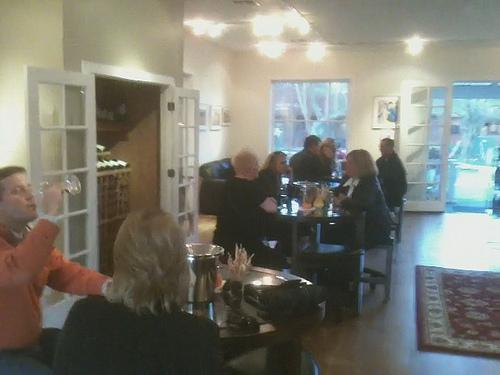Mention one prominent piece of furniture and its color in the image. A large red area rug is on the floor. Name one item found on the wall and describe its appearance. A wall picture frame is hanging, with a size of 12 by 12. What type of building is pictured and what feature do the doors have? A restaurant with a french door and a wood and glass door. What type of floor decor is present in the image? An oriental rug is spread on the floor. State the main purpose of the gathering in the image. People are dining and socializing in a restaurant. Briefly mention a group activity taking place in the image. A group of women are talking at the table. Name one accessory found on a table in the scene. An ice bucket is placed on a table in the restaurant. Describe one individual and what they are doing in the image. A man is drinking wine from a glass. Describe one clothing item a person is wearing in the image. A woman is wearing a black short sleeve shirt. Identify one person and list two of their facial features. The head of a man features an eye and a nose. 